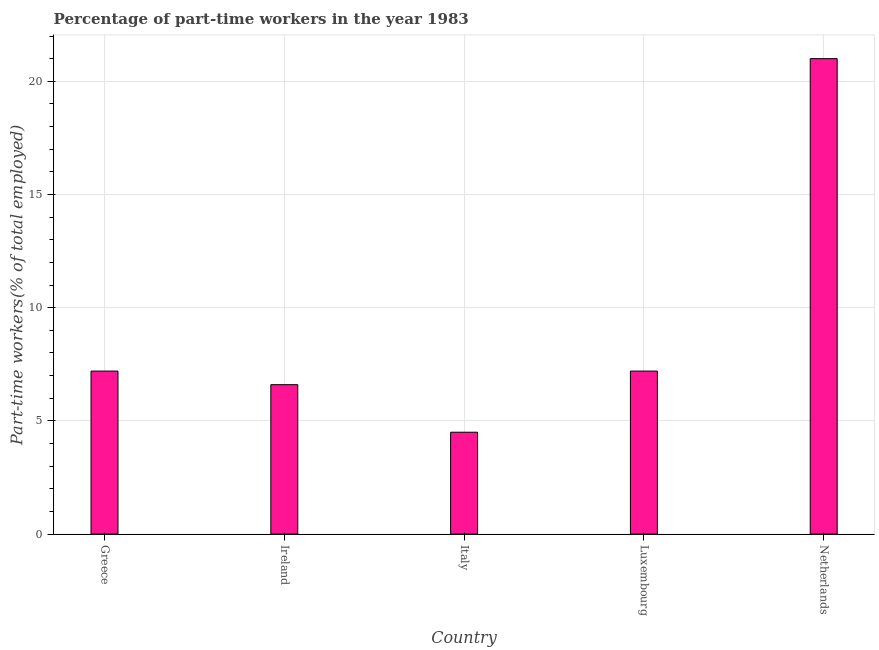Does the graph contain any zero values?
Offer a very short reply. No. Does the graph contain grids?
Ensure brevity in your answer.  Yes. What is the title of the graph?
Give a very brief answer. Percentage of part-time workers in the year 1983. What is the label or title of the Y-axis?
Your answer should be compact. Part-time workers(% of total employed). What is the percentage of part-time workers in Greece?
Provide a succinct answer. 7.2. In which country was the percentage of part-time workers maximum?
Make the answer very short. Netherlands. In which country was the percentage of part-time workers minimum?
Make the answer very short. Italy. What is the sum of the percentage of part-time workers?
Your answer should be compact. 46.5. What is the difference between the percentage of part-time workers in Ireland and Luxembourg?
Offer a terse response. -0.6. What is the average percentage of part-time workers per country?
Give a very brief answer. 9.3. What is the median percentage of part-time workers?
Ensure brevity in your answer.  7.2. What is the ratio of the percentage of part-time workers in Italy to that in Netherlands?
Ensure brevity in your answer.  0.21. Is the percentage of part-time workers in Greece less than that in Italy?
Offer a very short reply. No. Is the difference between the percentage of part-time workers in Italy and Luxembourg greater than the difference between any two countries?
Ensure brevity in your answer.  No. What is the difference between the highest and the second highest percentage of part-time workers?
Your answer should be compact. 13.8. Is the sum of the percentage of part-time workers in Greece and Netherlands greater than the maximum percentage of part-time workers across all countries?
Offer a terse response. Yes. In how many countries, is the percentage of part-time workers greater than the average percentage of part-time workers taken over all countries?
Make the answer very short. 1. What is the difference between two consecutive major ticks on the Y-axis?
Your answer should be very brief. 5. Are the values on the major ticks of Y-axis written in scientific E-notation?
Keep it short and to the point. No. What is the Part-time workers(% of total employed) in Greece?
Your answer should be compact. 7.2. What is the Part-time workers(% of total employed) in Ireland?
Keep it short and to the point. 6.6. What is the Part-time workers(% of total employed) in Luxembourg?
Your response must be concise. 7.2. What is the difference between the Part-time workers(% of total employed) in Ireland and Luxembourg?
Your answer should be very brief. -0.6. What is the difference between the Part-time workers(% of total employed) in Ireland and Netherlands?
Make the answer very short. -14.4. What is the difference between the Part-time workers(% of total employed) in Italy and Luxembourg?
Make the answer very short. -2.7. What is the difference between the Part-time workers(% of total employed) in Italy and Netherlands?
Provide a short and direct response. -16.5. What is the ratio of the Part-time workers(% of total employed) in Greece to that in Ireland?
Give a very brief answer. 1.09. What is the ratio of the Part-time workers(% of total employed) in Greece to that in Luxembourg?
Offer a terse response. 1. What is the ratio of the Part-time workers(% of total employed) in Greece to that in Netherlands?
Your answer should be compact. 0.34. What is the ratio of the Part-time workers(% of total employed) in Ireland to that in Italy?
Make the answer very short. 1.47. What is the ratio of the Part-time workers(% of total employed) in Ireland to that in Luxembourg?
Your response must be concise. 0.92. What is the ratio of the Part-time workers(% of total employed) in Ireland to that in Netherlands?
Your answer should be very brief. 0.31. What is the ratio of the Part-time workers(% of total employed) in Italy to that in Luxembourg?
Your answer should be compact. 0.62. What is the ratio of the Part-time workers(% of total employed) in Italy to that in Netherlands?
Provide a succinct answer. 0.21. What is the ratio of the Part-time workers(% of total employed) in Luxembourg to that in Netherlands?
Ensure brevity in your answer.  0.34. 